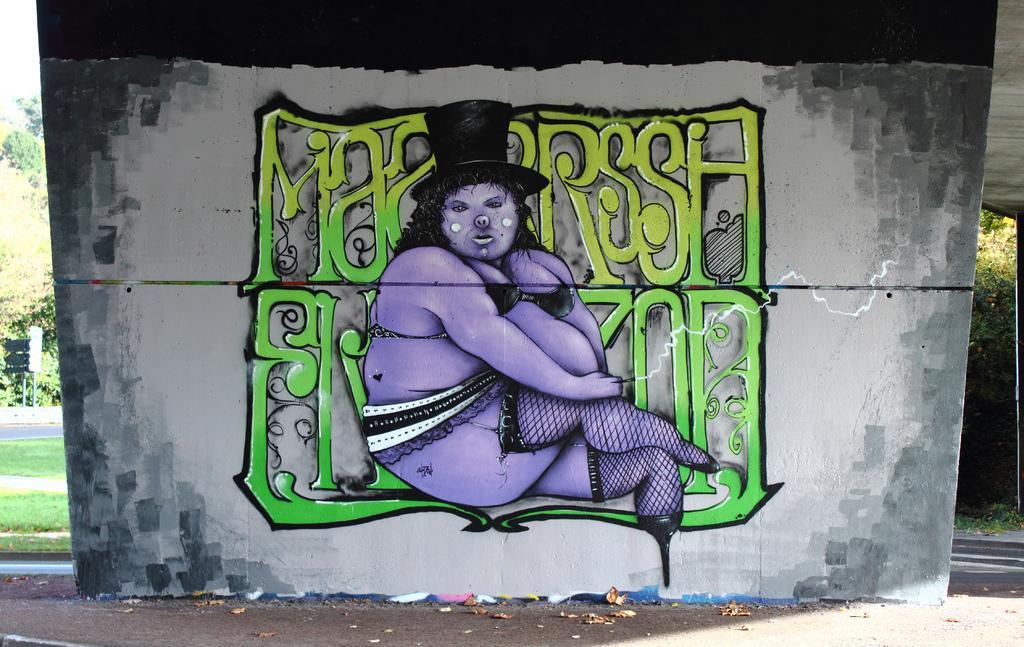Please provide a concise description of this image. In this image, It looks like a painting of a person and the letters on the wall. In the background, I can see the trees. On the left corner of the image, I think this is the grass. At the bottom of the image, It looks like a pathway. 